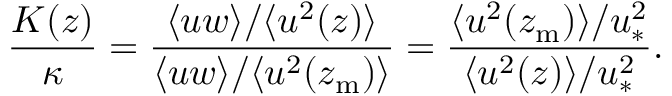<formula> <loc_0><loc_0><loc_500><loc_500>\frac { K ( z ) } { \kappa } = \frac { \langle u w \rangle / \langle u ^ { 2 } ( z ) \rangle } { \langle u w \rangle / \langle u ^ { 2 } ( z _ { m } ) \rangle } = \frac { \langle u ^ { 2 } ( z _ { m } ) \rangle / u _ { \ast } ^ { 2 } } { \langle u ^ { 2 } ( z ) \rangle / u _ { \ast } ^ { 2 } } .</formula> 